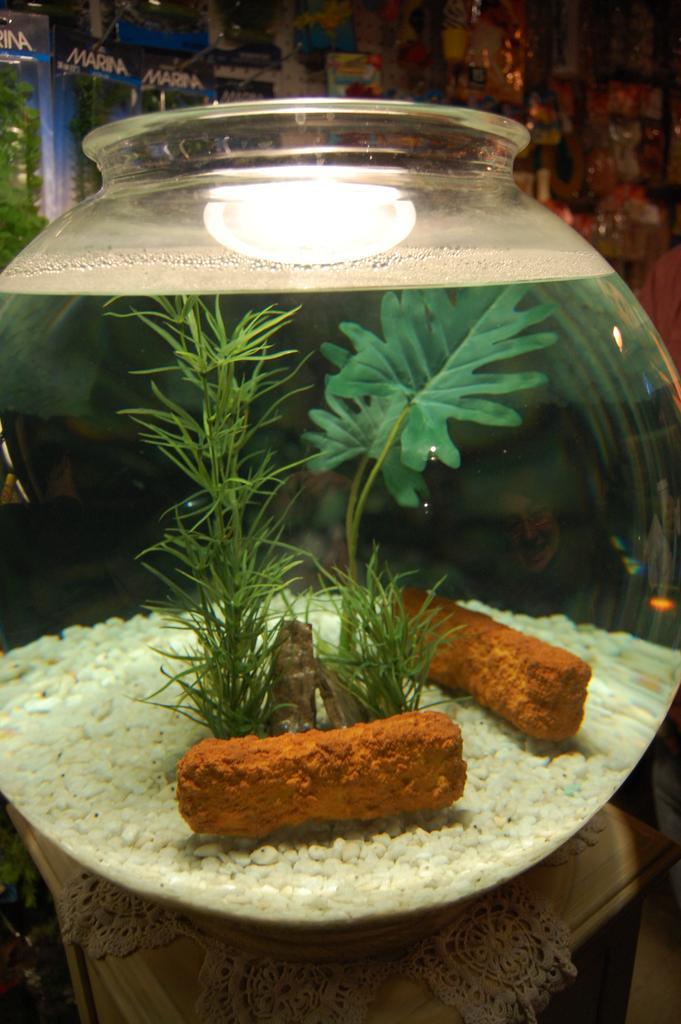Describe this image in one or two sentences. In this image I can see glass bowl in the table, inside the bowl there is so much of water, grass, leaves, crystals and few other things, behind the bowl there are few banners. 